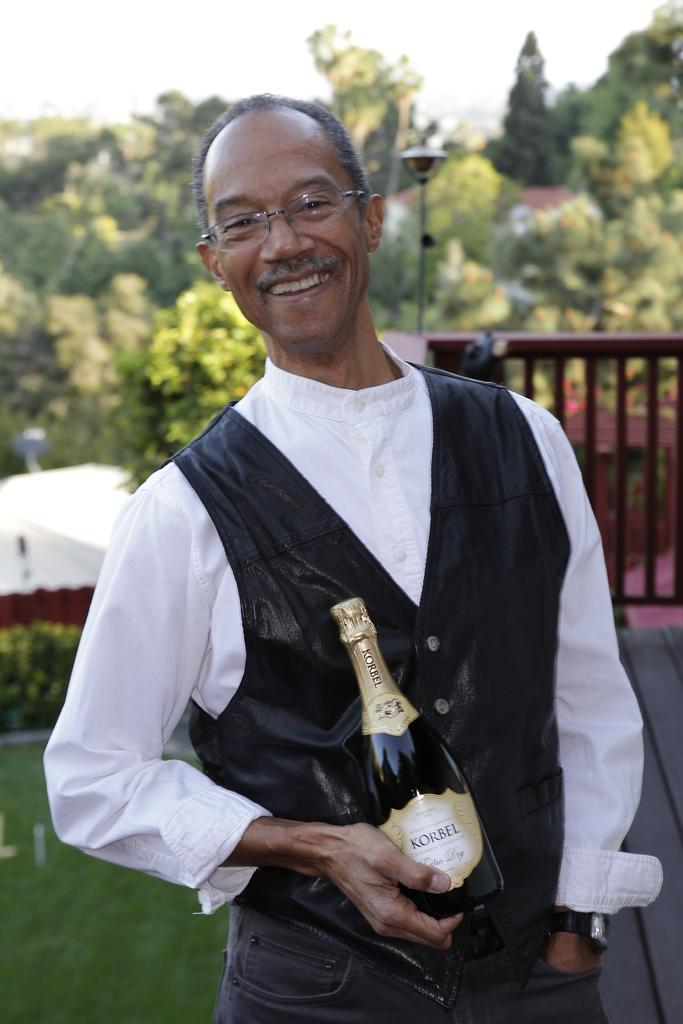What is the main subject of the image? There is a man standing in the center of the image. What is the man holding in his hand? The man is holding a bottle in his hand. What type of clothing is the man wearing? The man is wearing a jacket. What can be seen in the background of the image? There is a fence, a light, trees, and the sky visible in the background of the image. What type of flowers can be seen growing near the fence in the image? There are no flowers visible in the image; the background features a fence, a light, trees, and the sky. 